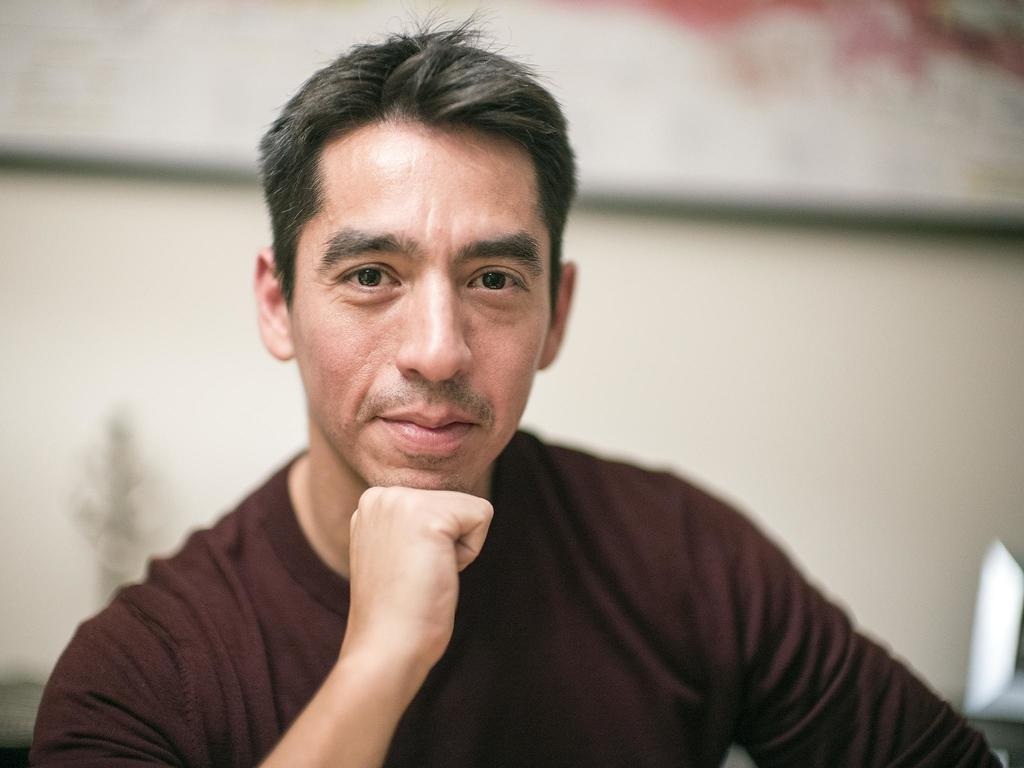What is the main subject of the image? There is a person in the image. Can you describe the background of the image? The background of the image is blurred. What type of flame can be seen on the table in the image? There is no flame or table present in the image; it only features a person with a blurred background. 